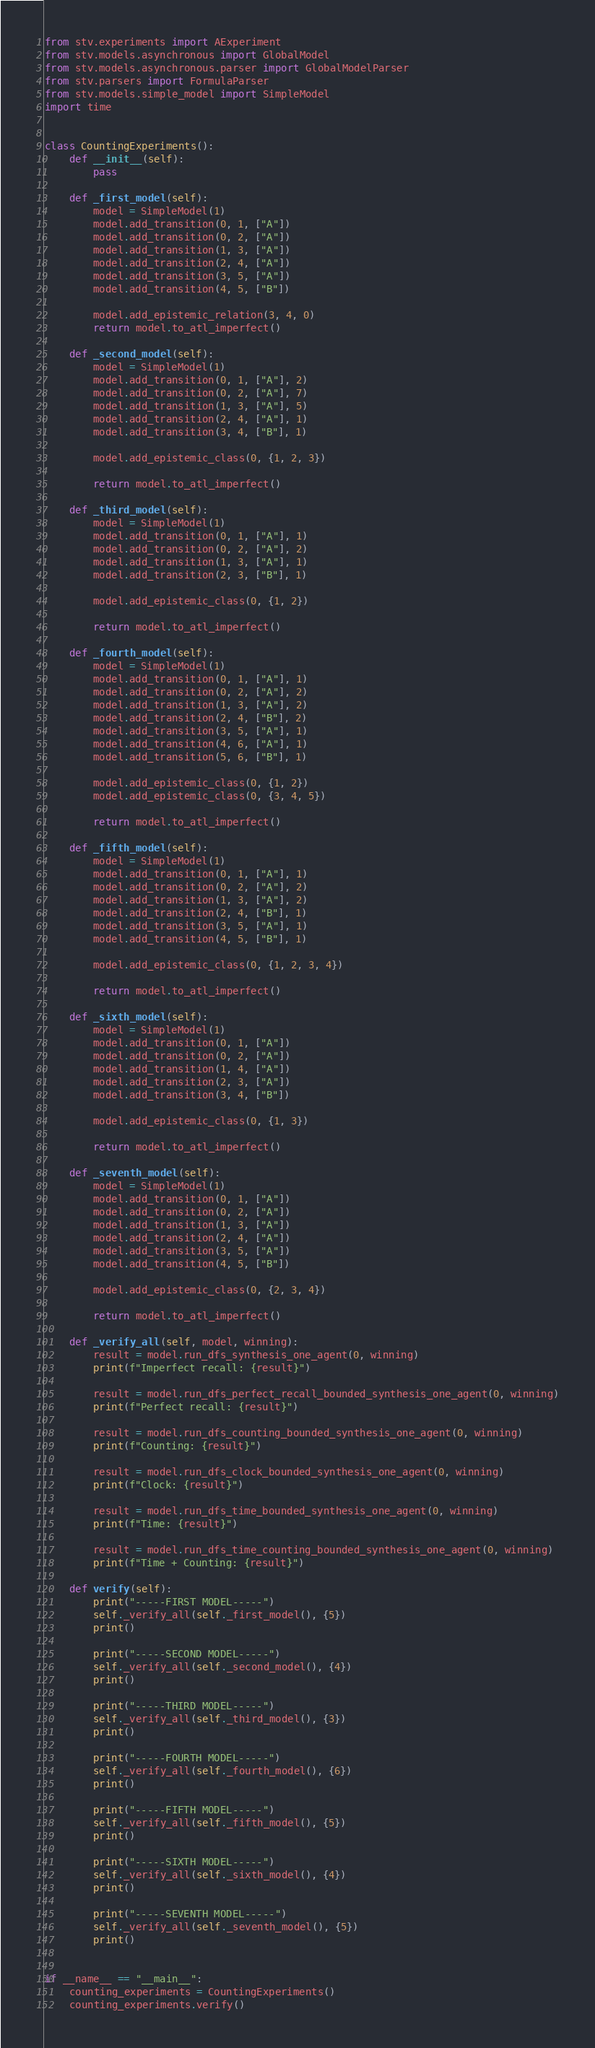<code> <loc_0><loc_0><loc_500><loc_500><_Python_>from stv.experiments import AExperiment
from stv.models.asynchronous import GlobalModel
from stv.models.asynchronous.parser import GlobalModelParser
from stv.parsers import FormulaParser
from stv.models.simple_model import SimpleModel
import time


class CountingExperiments():
    def __init__(self):
        pass

    def _first_model(self):
        model = SimpleModel(1)
        model.add_transition(0, 1, ["A"])
        model.add_transition(0, 2, ["A"])
        model.add_transition(1, 3, ["A"])
        model.add_transition(2, 4, ["A"])
        model.add_transition(3, 5, ["A"])
        model.add_transition(4, 5, ["B"])

        model.add_epistemic_relation(3, 4, 0)
        return model.to_atl_imperfect()

    def _second_model(self):
        model = SimpleModel(1)
        model.add_transition(0, 1, ["A"], 2)
        model.add_transition(0, 2, ["A"], 7)
        model.add_transition(1, 3, ["A"], 5)
        model.add_transition(2, 4, ["A"], 1)
        model.add_transition(3, 4, ["B"], 1)

        model.add_epistemic_class(0, {1, 2, 3})

        return model.to_atl_imperfect()

    def _third_model(self):
        model = SimpleModel(1)
        model.add_transition(0, 1, ["A"], 1)
        model.add_transition(0, 2, ["A"], 2)
        model.add_transition(1, 3, ["A"], 1)
        model.add_transition(2, 3, ["B"], 1)

        model.add_epistemic_class(0, {1, 2})

        return model.to_atl_imperfect()

    def _fourth_model(self):
        model = SimpleModel(1)
        model.add_transition(0, 1, ["A"], 1)
        model.add_transition(0, 2, ["A"], 2)
        model.add_transition(1, 3, ["A"], 2)
        model.add_transition(2, 4, ["B"], 2)
        model.add_transition(3, 5, ["A"], 1)
        model.add_transition(4, 6, ["A"], 1)
        model.add_transition(5, 6, ["B"], 1)

        model.add_epistemic_class(0, {1, 2})
        model.add_epistemic_class(0, {3, 4, 5})

        return model.to_atl_imperfect()

    def _fifth_model(self):
        model = SimpleModel(1)
        model.add_transition(0, 1, ["A"], 1)
        model.add_transition(0, 2, ["A"], 2)
        model.add_transition(1, 3, ["A"], 2)
        model.add_transition(2, 4, ["B"], 1)
        model.add_transition(3, 5, ["A"], 1)
        model.add_transition(4, 5, ["B"], 1)

        model.add_epistemic_class(0, {1, 2, 3, 4})

        return model.to_atl_imperfect()

    def _sixth_model(self):
        model = SimpleModel(1)
        model.add_transition(0, 1, ["A"])
        model.add_transition(0, 2, ["A"])
        model.add_transition(1, 4, ["A"])
        model.add_transition(2, 3, ["A"])
        model.add_transition(3, 4, ["B"])

        model.add_epistemic_class(0, {1, 3})

        return model.to_atl_imperfect()

    def _seventh_model(self):
        model = SimpleModel(1)
        model.add_transition(0, 1, ["A"])
        model.add_transition(0, 2, ["A"])
        model.add_transition(1, 3, ["A"])
        model.add_transition(2, 4, ["A"])
        model.add_transition(3, 5, ["A"])
        model.add_transition(4, 5, ["B"])

        model.add_epistemic_class(0, {2, 3, 4})

        return model.to_atl_imperfect()

    def _verify_all(self, model, winning):
        result = model.run_dfs_synthesis_one_agent(0, winning)
        print(f"Imperfect recall: {result}")

        result = model.run_dfs_perfect_recall_bounded_synthesis_one_agent(0, winning)
        print(f"Perfect recall: {result}")

        result = model.run_dfs_counting_bounded_synthesis_one_agent(0, winning)
        print(f"Counting: {result}")

        result = model.run_dfs_clock_bounded_synthesis_one_agent(0, winning)
        print(f"Clock: {result}")

        result = model.run_dfs_time_bounded_synthesis_one_agent(0, winning)
        print(f"Time: {result}")

        result = model.run_dfs_time_counting_bounded_synthesis_one_agent(0, winning)
        print(f"Time + Counting: {result}")

    def verify(self):
        print("-----FIRST MODEL-----")
        self._verify_all(self._first_model(), {5})
        print()

        print("-----SECOND MODEL-----")
        self._verify_all(self._second_model(), {4})
        print()

        print("-----THIRD MODEL-----")
        self._verify_all(self._third_model(), {3})
        print()

        print("-----FOURTH MODEL-----")
        self._verify_all(self._fourth_model(), {6})
        print()

        print("-----FIFTH MODEL-----")
        self._verify_all(self._fifth_model(), {5})
        print()

        print("-----SIXTH MODEL-----")
        self._verify_all(self._sixth_model(), {4})
        print()

        print("-----SEVENTH MODEL-----")
        self._verify_all(self._seventh_model(), {5})
        print()


if __name__ == "__main__":
    counting_experiments = CountingExperiments()
    counting_experiments.verify()
</code> 